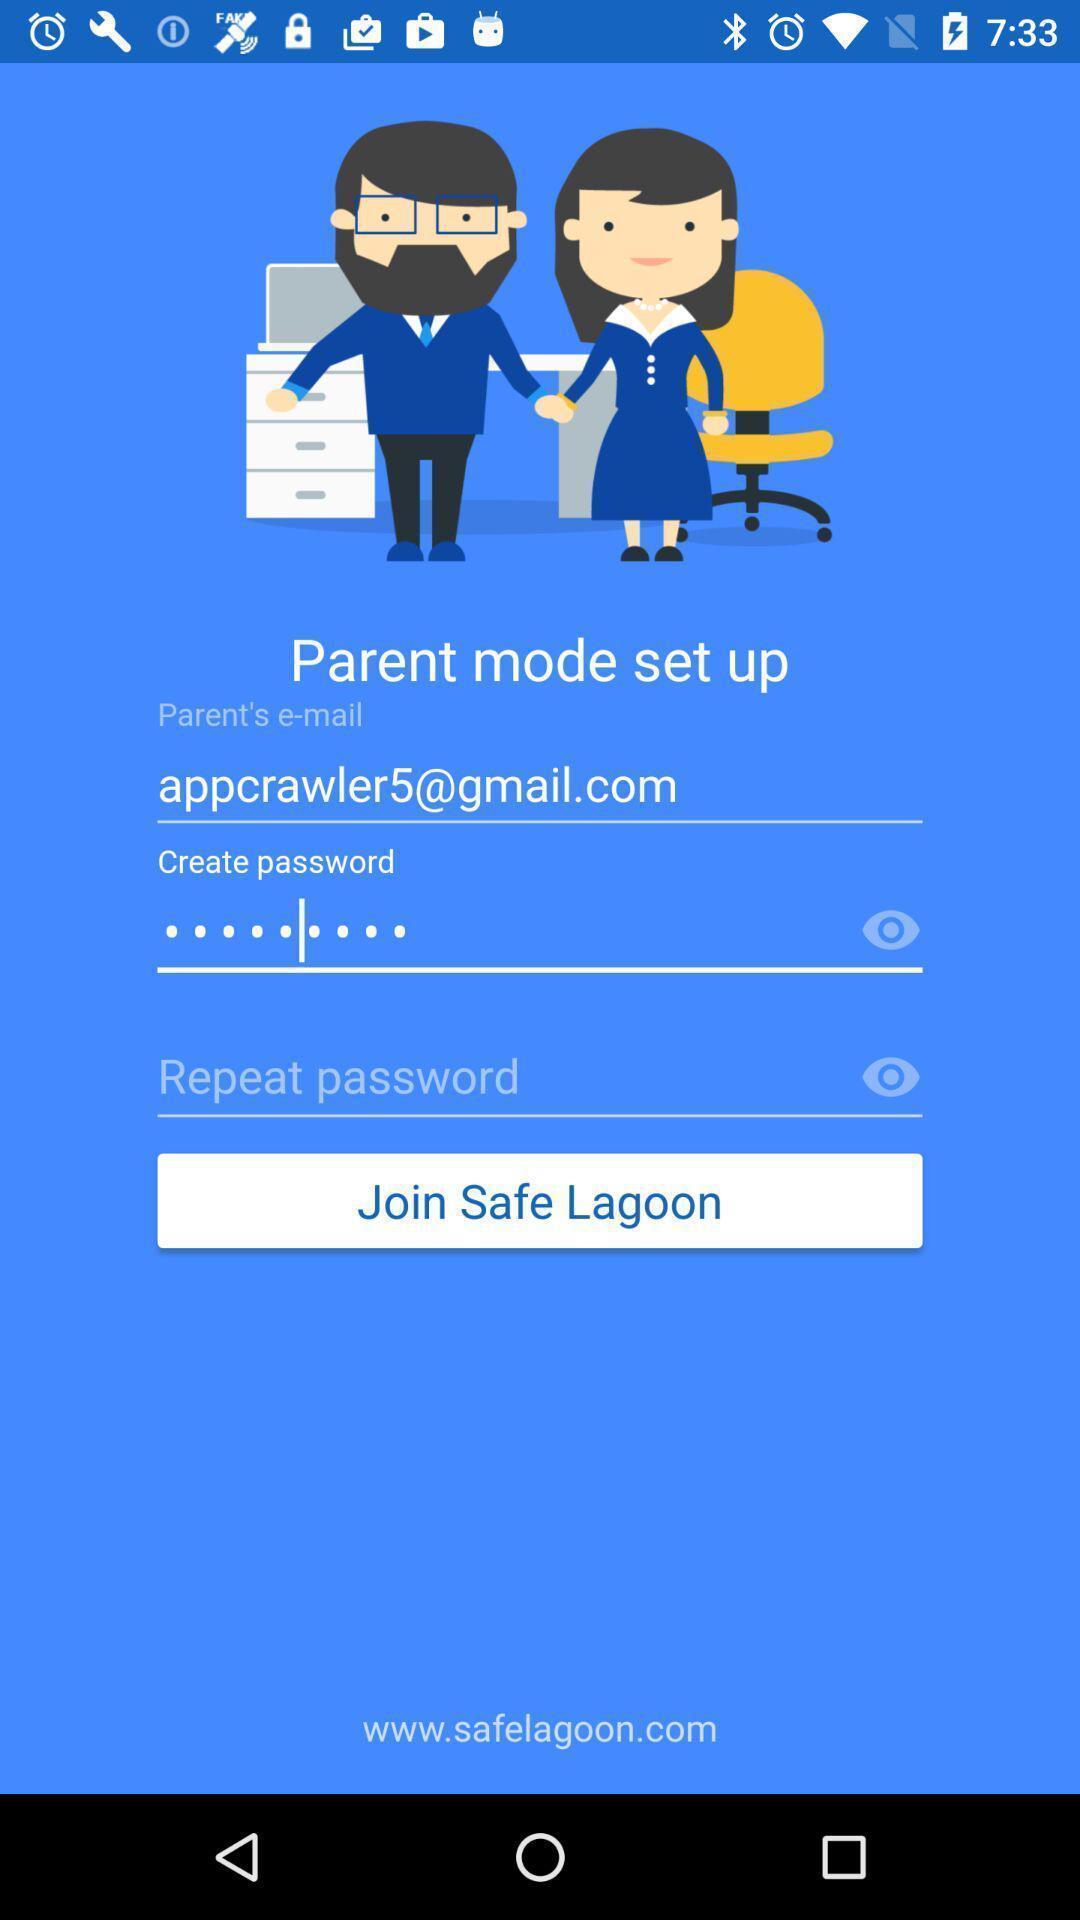Tell me about the visual elements in this screen capture. Page displaying information for signing into account. 